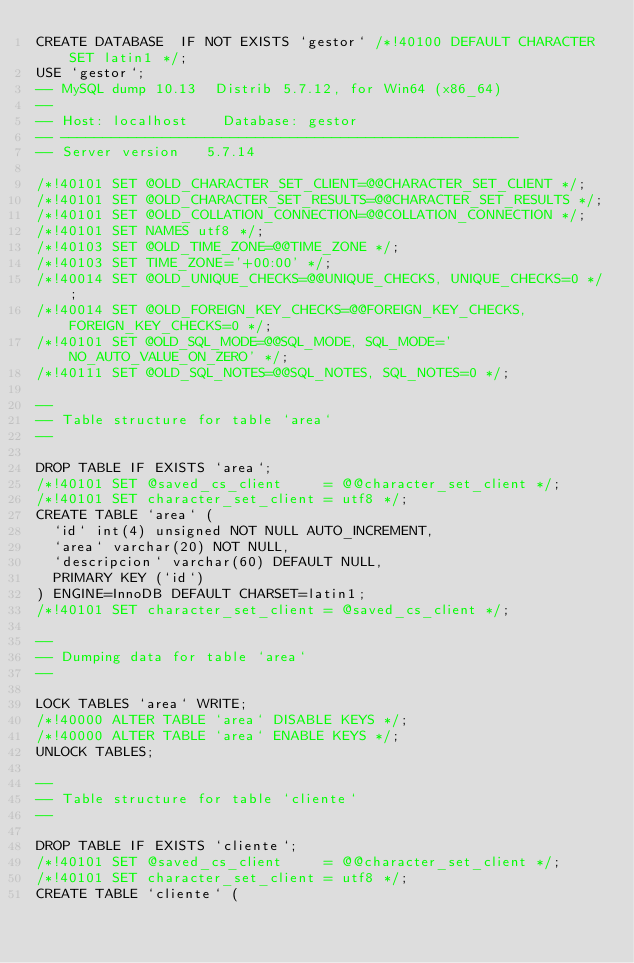<code> <loc_0><loc_0><loc_500><loc_500><_SQL_>CREATE DATABASE  IF NOT EXISTS `gestor` /*!40100 DEFAULT CHARACTER SET latin1 */;
USE `gestor`;
-- MySQL dump 10.13  Distrib 5.7.12, for Win64 (x86_64)
--
-- Host: localhost    Database: gestor
-- ------------------------------------------------------
-- Server version	5.7.14

/*!40101 SET @OLD_CHARACTER_SET_CLIENT=@@CHARACTER_SET_CLIENT */;
/*!40101 SET @OLD_CHARACTER_SET_RESULTS=@@CHARACTER_SET_RESULTS */;
/*!40101 SET @OLD_COLLATION_CONNECTION=@@COLLATION_CONNECTION */;
/*!40101 SET NAMES utf8 */;
/*!40103 SET @OLD_TIME_ZONE=@@TIME_ZONE */;
/*!40103 SET TIME_ZONE='+00:00' */;
/*!40014 SET @OLD_UNIQUE_CHECKS=@@UNIQUE_CHECKS, UNIQUE_CHECKS=0 */;
/*!40014 SET @OLD_FOREIGN_KEY_CHECKS=@@FOREIGN_KEY_CHECKS, FOREIGN_KEY_CHECKS=0 */;
/*!40101 SET @OLD_SQL_MODE=@@SQL_MODE, SQL_MODE='NO_AUTO_VALUE_ON_ZERO' */;
/*!40111 SET @OLD_SQL_NOTES=@@SQL_NOTES, SQL_NOTES=0 */;

--
-- Table structure for table `area`
--

DROP TABLE IF EXISTS `area`;
/*!40101 SET @saved_cs_client     = @@character_set_client */;
/*!40101 SET character_set_client = utf8 */;
CREATE TABLE `area` (
  `id` int(4) unsigned NOT NULL AUTO_INCREMENT,
  `area` varchar(20) NOT NULL,
  `descripcion` varchar(60) DEFAULT NULL,
  PRIMARY KEY (`id`)
) ENGINE=InnoDB DEFAULT CHARSET=latin1;
/*!40101 SET character_set_client = @saved_cs_client */;

--
-- Dumping data for table `area`
--

LOCK TABLES `area` WRITE;
/*!40000 ALTER TABLE `area` DISABLE KEYS */;
/*!40000 ALTER TABLE `area` ENABLE KEYS */;
UNLOCK TABLES;

--
-- Table structure for table `cliente`
--

DROP TABLE IF EXISTS `cliente`;
/*!40101 SET @saved_cs_client     = @@character_set_client */;
/*!40101 SET character_set_client = utf8 */;
CREATE TABLE `cliente` (</code> 